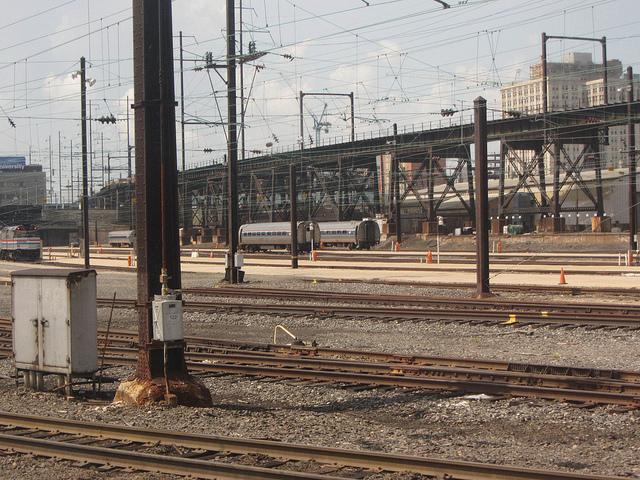Is this a train?
Quick response, please. Yes. Is the train close?
Quick response, please. No. What crosses in this picture?
Be succinct. Train. Where is the train?
Concise answer only. Tracks. What is the mode of transportation shown?
Quick response, please. Train. What is tall in the background of the photo?
Quick response, please. Building. 